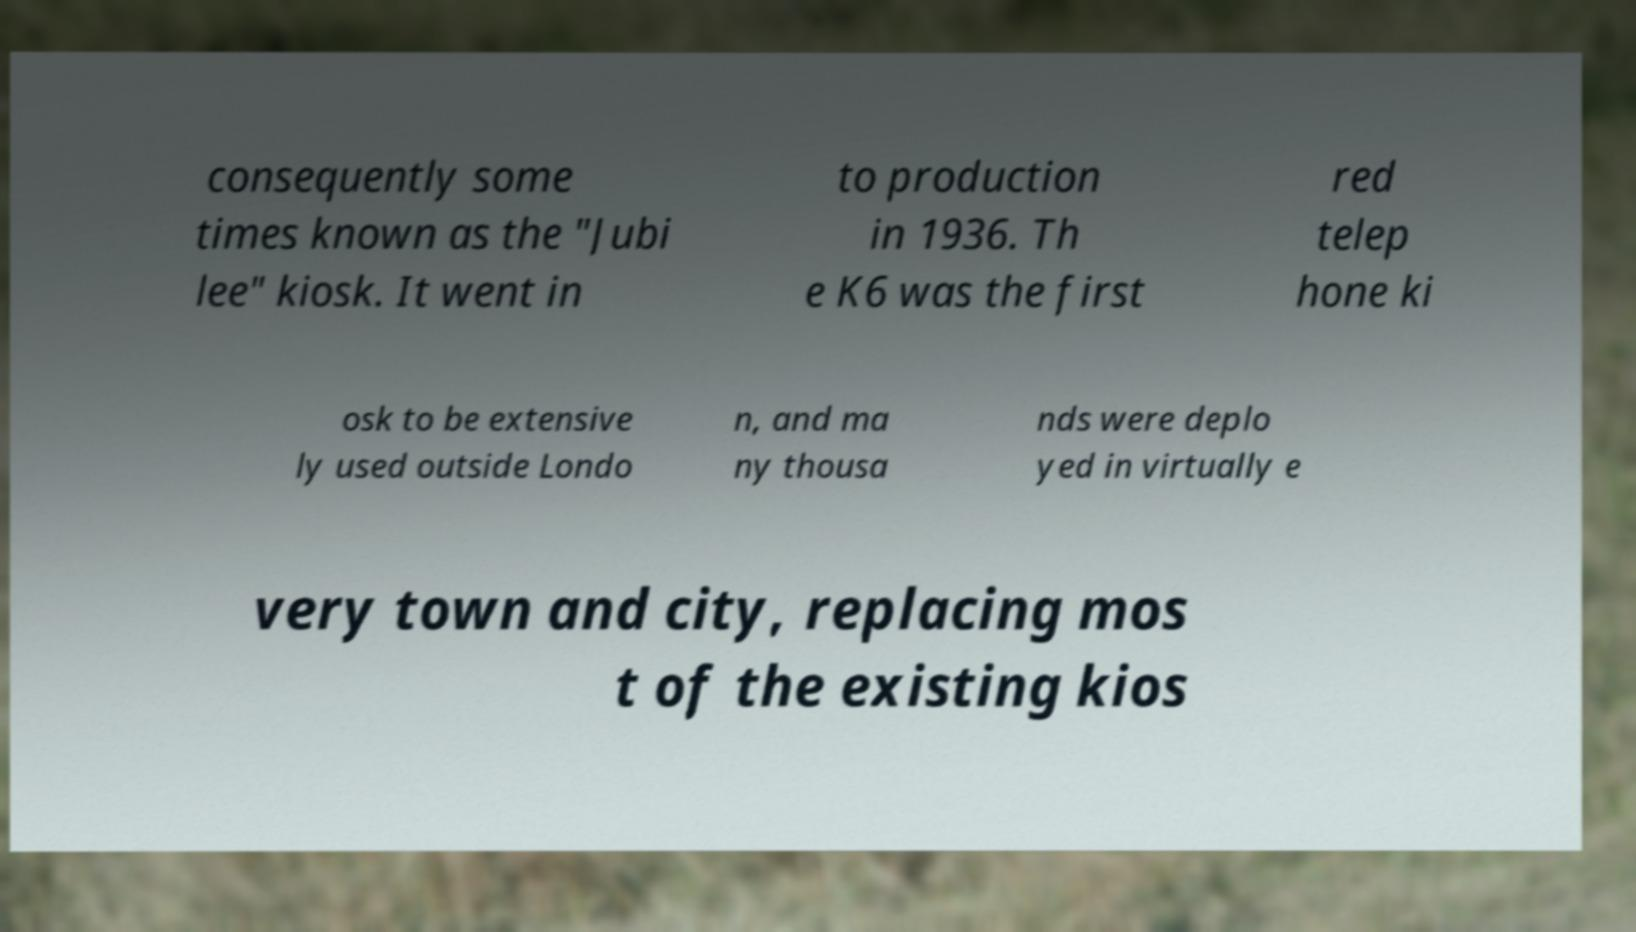Could you assist in decoding the text presented in this image and type it out clearly? consequently some times known as the "Jubi lee" kiosk. It went in to production in 1936. Th e K6 was the first red telep hone ki osk to be extensive ly used outside Londo n, and ma ny thousa nds were deplo yed in virtually e very town and city, replacing mos t of the existing kios 